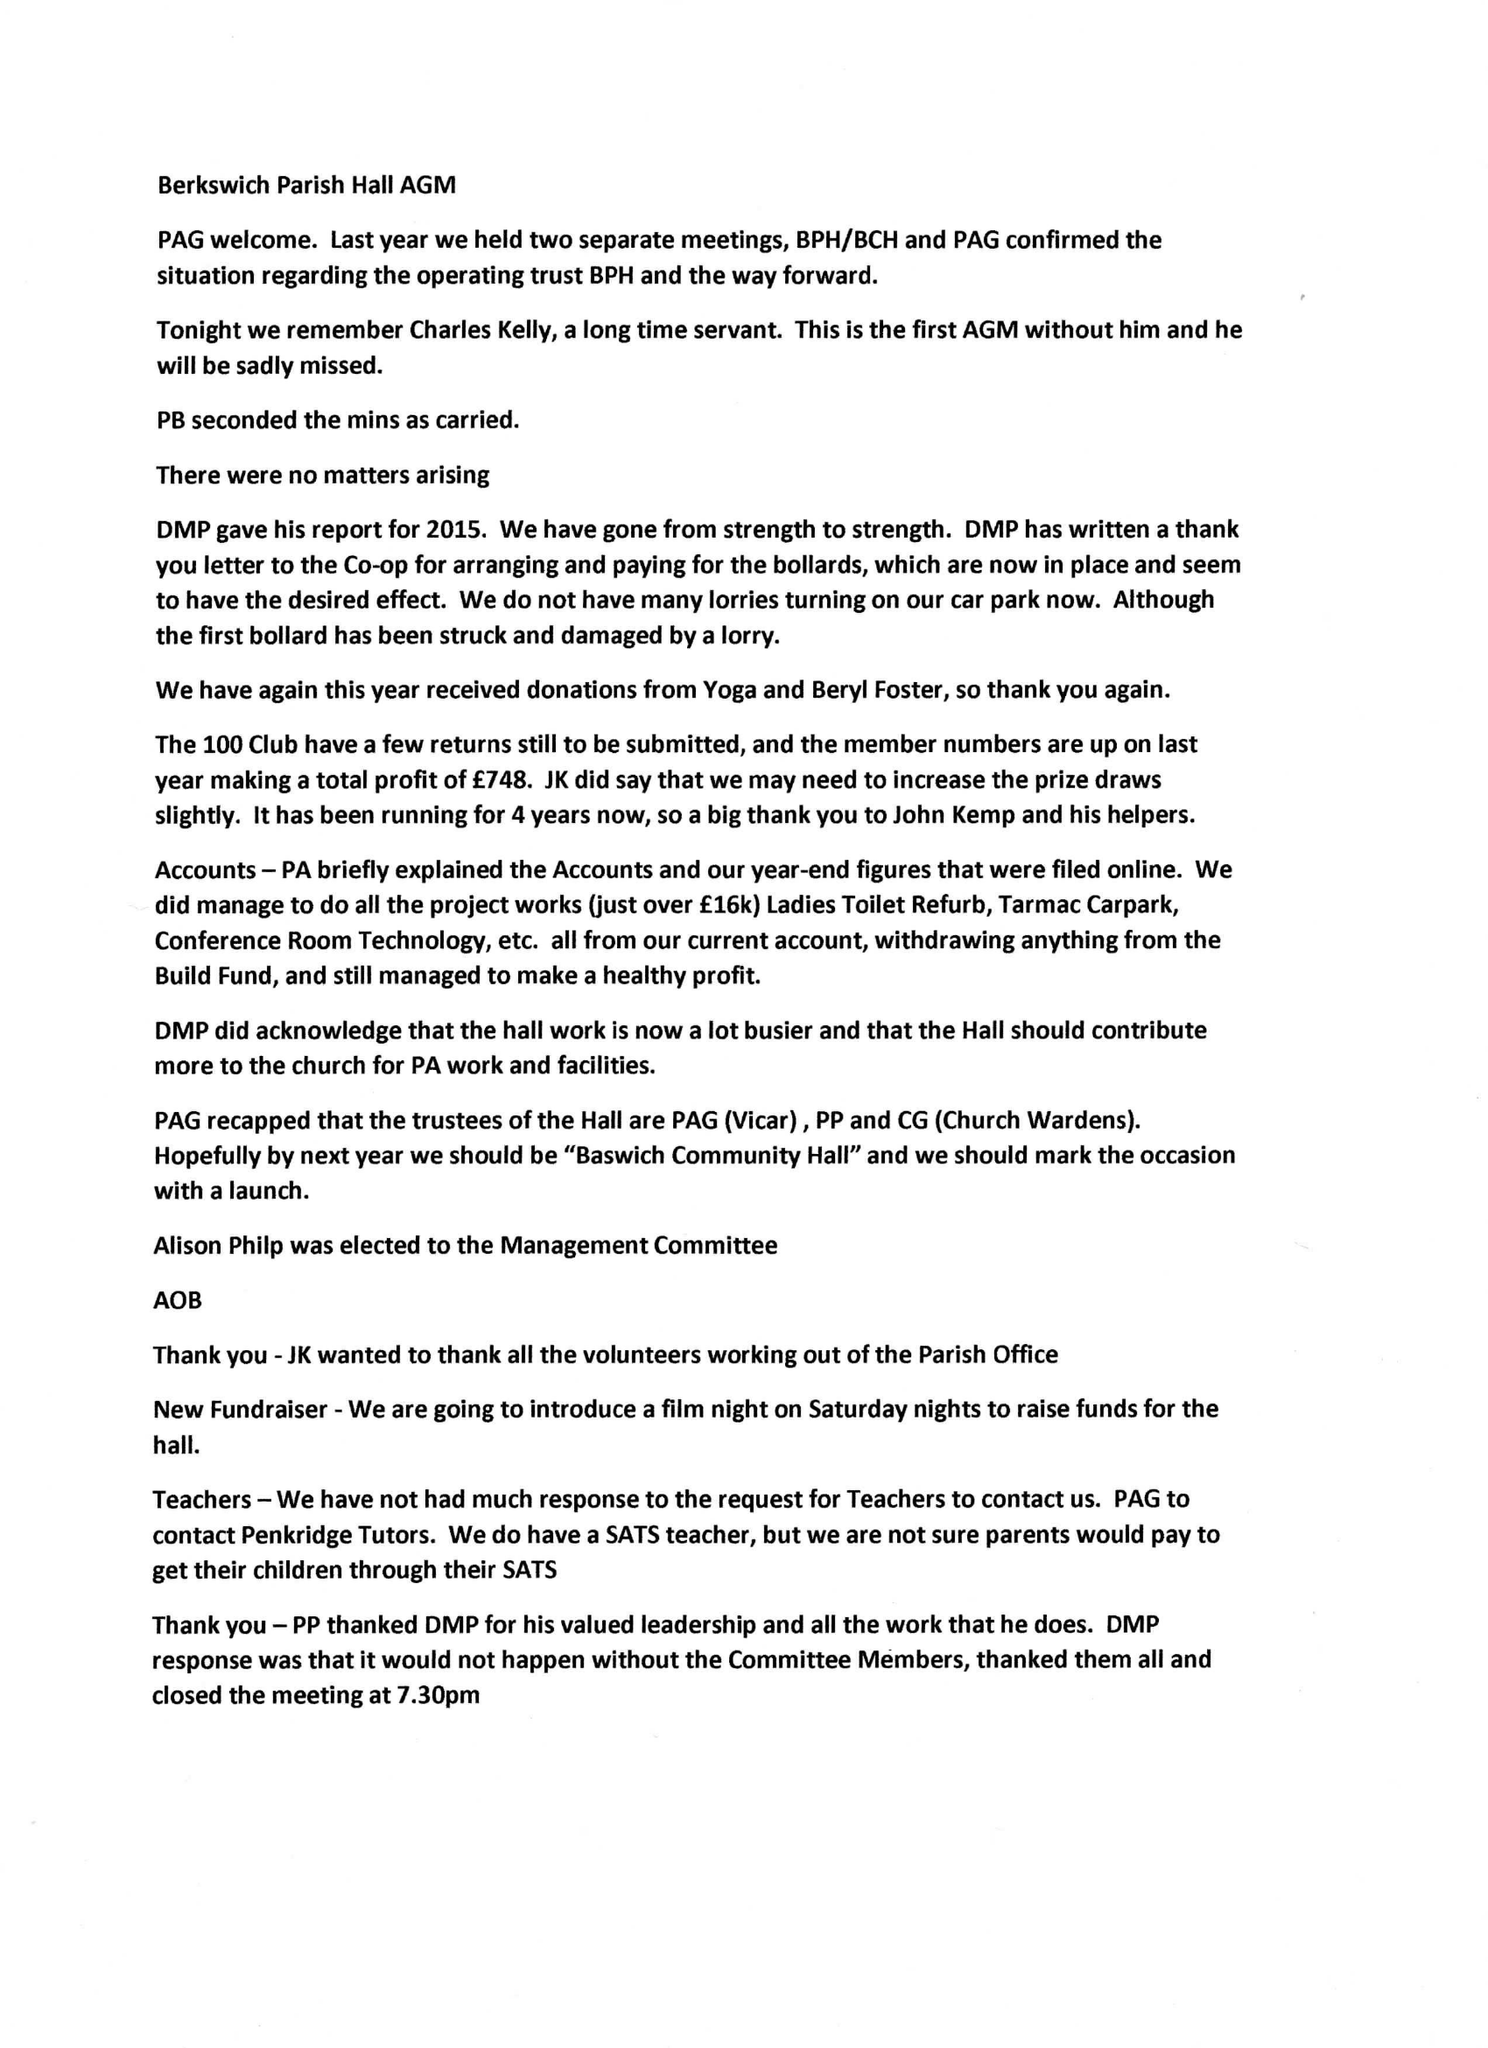What is the value for the spending_annually_in_british_pounds?
Answer the question using a single word or phrase. 18158.00 